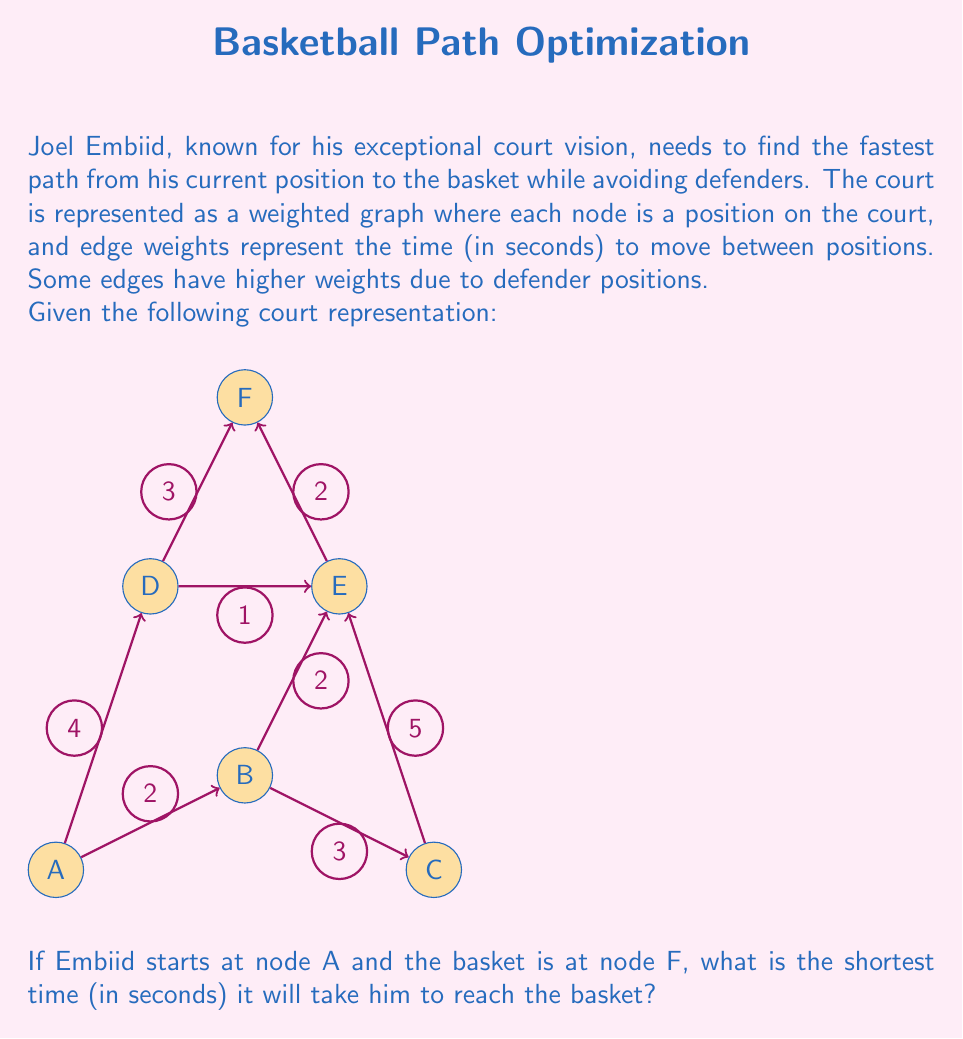Solve this math problem. To solve this problem, we'll use Dijkstra's algorithm to find the shortest path from node A to node F. Here's a step-by-step explanation:

1) Initialize distances:
   $d[A] = 0$, $d[B] = \infty$, $d[C] = \infty$, $d[D] = \infty$, $d[E] = \infty$, $d[F] = \infty$

2) Start from node A:
   - Update $d[B] = 2$
   - Update $d[D] = 4$

3) Choose the node with the smallest distance (B):
   - Update $d[C] = 2 + 3 = 5$
   - Update $d[E] = 2 + 2 = 4$

4) Choose the next smallest distance (D or E, both 4):
   Let's choose D:
   - Update $d[E] = \min(4, 4 + 1) = 4$ (no change)
   - Update $d[F] = 4 + 3 = 7$

5) Move to E:
   - Update $d[F] = \min(7, 4 + 2) = 6$

6) All nodes have been visited, and the shortest path to F has been found.

The shortest path is A -> B -> E -> F, with a total time of 6 seconds.
Answer: 6 seconds 